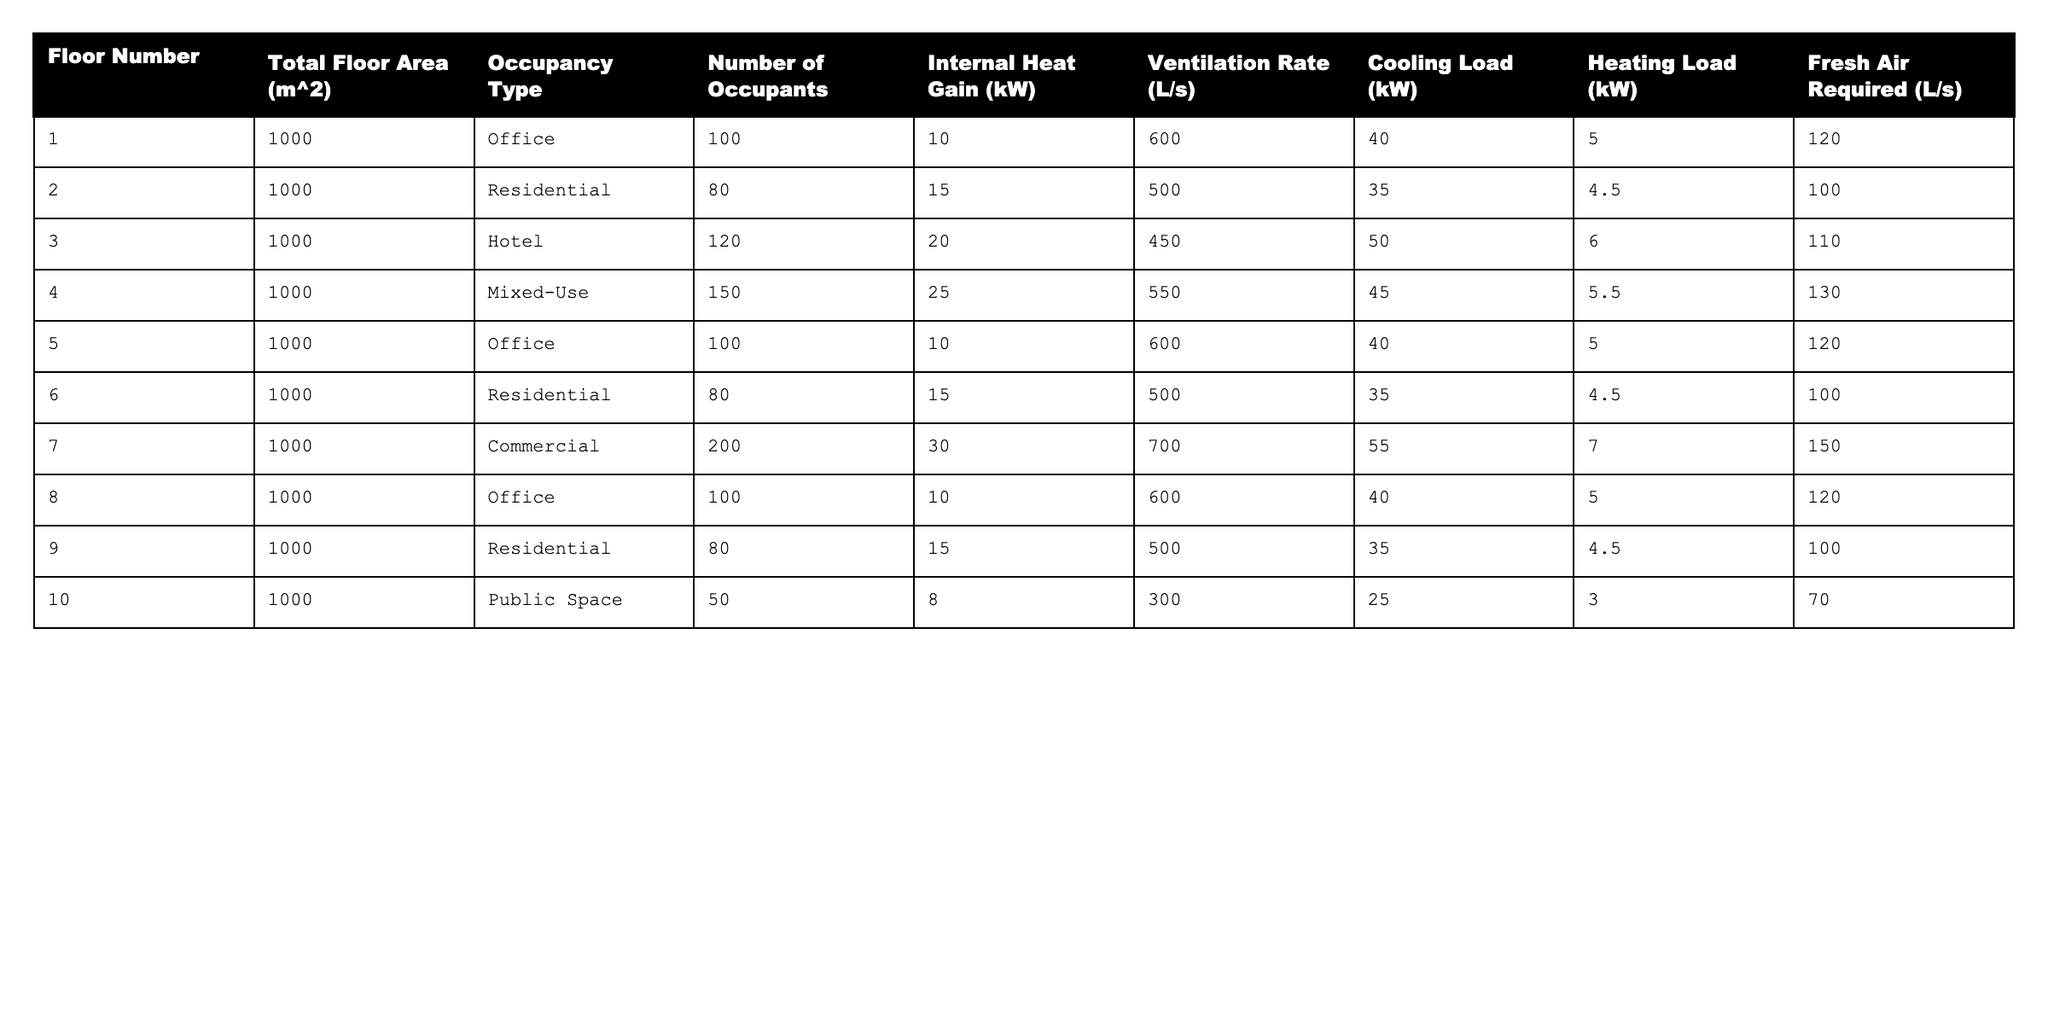What is the ventilation rate for the mixed-use floor? In the table, under the mixed-use row, the ventilation rate is listed as 550 L/s.
Answer: 550 L/s What is the total number of occupants across all floors? By adding the number of occupants from each row: 100 + 80 + 120 + 150 + 100 + 80 + 200 + 100 + 80 + 50 = 1060.
Answer: 1060 What is the highest cooling load among the floors? Looking at the cooling load column, the highest value is 55 kW, which corresponds to the commercial floor (floor 7).
Answer: 55 kW Does the office floor with the most occupants have the highest internal heat gain? Comparing the office floor with the most occupants (floor 1 & 5 with 100 occupants) having 10 kW internal heat gain, the highest internal heat gain is 30 kW from the commercial floor. Therefore, no, it does not have the highest internal heat gain.
Answer: No What is the average fresh air required for residential floors? The fresh air required for residential floors (floors 2, 6, and 9) are 100 L/s, 100 L/s, and 100 L/s respectively. Calculating the average: (100 + 100 + 100) / 3 = 100 L/s.
Answer: 100 L/s What is the combined heating load for all the floors? Adding the heating loads: 5 + 4.5 + 6 + 5.5 + 5 + 4.5 + 7 + 5 + 4.5 + 3 = 56.
Answer: 56 kW Which occupancy type has the greatest internal heat gain, and how much is it? Reviewing the internal heat gain, the commercial occupancy has the highest value at 30 kW.
Answer: Commercial, 30 kW If cooling load for the hotel floor were to be reduced to 40 kW, what would be the new average cooling load across all floors? The original total cooling load is 40 + 35 + 50 + 45 + 40 + 35 + 55 + 40 + 35 + 25 = 395 kW. If the hotel cooling load changes to 40 kW, the new total would be 395 - 50 + 40 = 385 kW. With 10 floors, the new average is 385 / 10 = 38.5 kW.
Answer: 38.5 kW What is the difference between the highest and lowest total floor area? Since all floors have a total floor area of 1000 m^2, the difference between highest and lowest is 1000 - 1000 = 0.
Answer: 0 m^2 Which floor requires the most fresh air? The mixed-use floor (floor 4) requires the most fresh air at 130 L/s based on the fresh air required column.
Answer: Floor 4, 130 L/s 